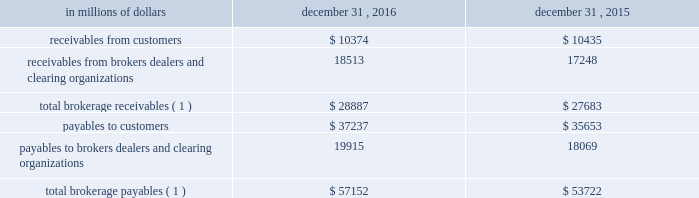12 .
Brokerage receivables and brokerage payables citi has receivables and payables for financial instruments sold to and purchased from brokers , dealers and customers , which arise in the ordinary course of business .
Citi is exposed to risk of loss from the inability of brokers , dealers or customers to pay for purchases or to deliver the financial instruments sold , in which case citi would have to sell or purchase the financial instruments at prevailing market prices .
Credit risk is reduced to the extent that an exchange or clearing organization acts as a counterparty to the transaction and replaces the broker , dealer or customer in question .
Citi seeks to protect itself from the risks associated with customer activities by requiring customers to maintain margin collateral in compliance with regulatory and internal guidelines .
Margin levels are monitored daily , and customers deposit additional collateral as required .
Where customers cannot meet collateral requirements , citi may liquidate sufficient underlying financial instruments to bring the customer into compliance with the required margin level .
Exposure to credit risk is impacted by market volatility , which may impair the ability of clients to satisfy their obligations to citi .
Credit limits are established and closely monitored for customers and for brokers and dealers engaged in forwards , futures and other transactions deemed to be credit sensitive .
Brokerage receivables and brokerage payables consisted of the following: .
Payables to brokers , dealers , and clearing organizations 19915 18069 total brokerage payables ( 1 ) $ 57152 $ 53722 ( 1 ) includes brokerage receivables and payables recorded by citi broker- dealer entities that are accounted for in accordance with the aicpa accounting guide for brokers and dealers in securities as codified in asc 940-320. .
What was the percent of the change in the 8 total brokerage payable from 2015 to 2016? 
Computations: ((57152 - 53722) / 53722)
Answer: 0.06385. 12 .
Brokerage receivables and brokerage payables citi has receivables and payables for financial instruments sold to and purchased from brokers , dealers and customers , which arise in the ordinary course of business .
Citi is exposed to risk of loss from the inability of brokers , dealers or customers to pay for purchases or to deliver the financial instruments sold , in which case citi would have to sell or purchase the financial instruments at prevailing market prices .
Credit risk is reduced to the extent that an exchange or clearing organization acts as a counterparty to the transaction and replaces the broker , dealer or customer in question .
Citi seeks to protect itself from the risks associated with customer activities by requiring customers to maintain margin collateral in compliance with regulatory and internal guidelines .
Margin levels are monitored daily , and customers deposit additional collateral as required .
Where customers cannot meet collateral requirements , citi may liquidate sufficient underlying financial instruments to bring the customer into compliance with the required margin level .
Exposure to credit risk is impacted by market volatility , which may impair the ability of clients to satisfy their obligations to citi .
Credit limits are established and closely monitored for customers and for brokers and dealers engaged in forwards , futures and other transactions deemed to be credit sensitive .
Brokerage receivables and brokerage payables consisted of the following: .
Payables to brokers , dealers , and clearing organizations 19915 18069 total brokerage payables ( 1 ) $ 57152 $ 53722 ( 1 ) includes brokerage receivables and payables recorded by citi broker- dealer entities that are accounted for in accordance with the aicpa accounting guide for brokers and dealers in securities as codified in asc 940-320. .
What was the ratio of the total brokerage payable to the total brokerage receivables in 2016? 
Rationale: in 2016 there was $ 1.98 of total brokerage payables per $ 1 of total brokerage receivables
Computations: (57152 / 28887)
Answer: 1.97847. 